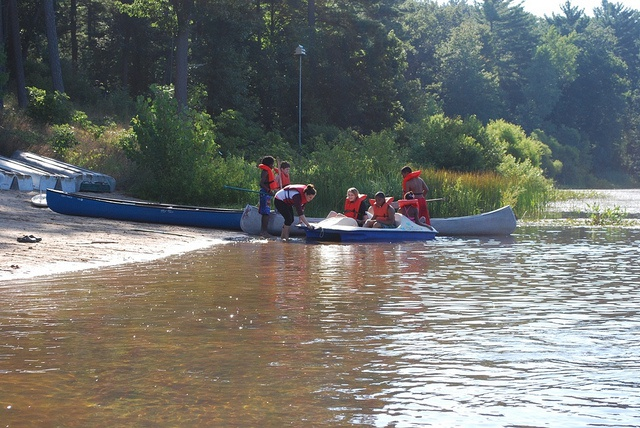Describe the objects in this image and their specific colors. I can see boat in black, navy, gray, and darkgray tones, boat in black, navy, white, and darkgray tones, boat in black and gray tones, boat in black, blue, gray, white, and darkblue tones, and boat in black and gray tones in this image. 